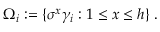<formula> <loc_0><loc_0><loc_500><loc_500>\Omega _ { i } \colon = \{ \sigma ^ { x } \gamma _ { i } \colon 1 \leq x \leq h \} \, .</formula> 